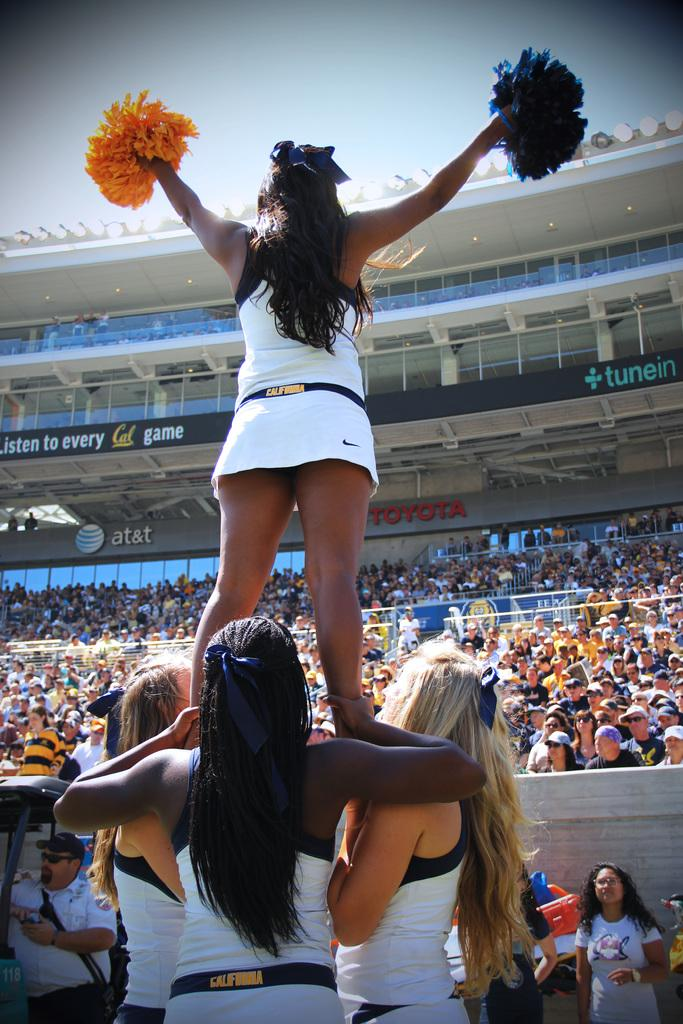Provide a one-sentence caption for the provided image. A cheerleader is held up by three others and waves her pom poms at a big crowd seated in a Toyota sponsored stand. 